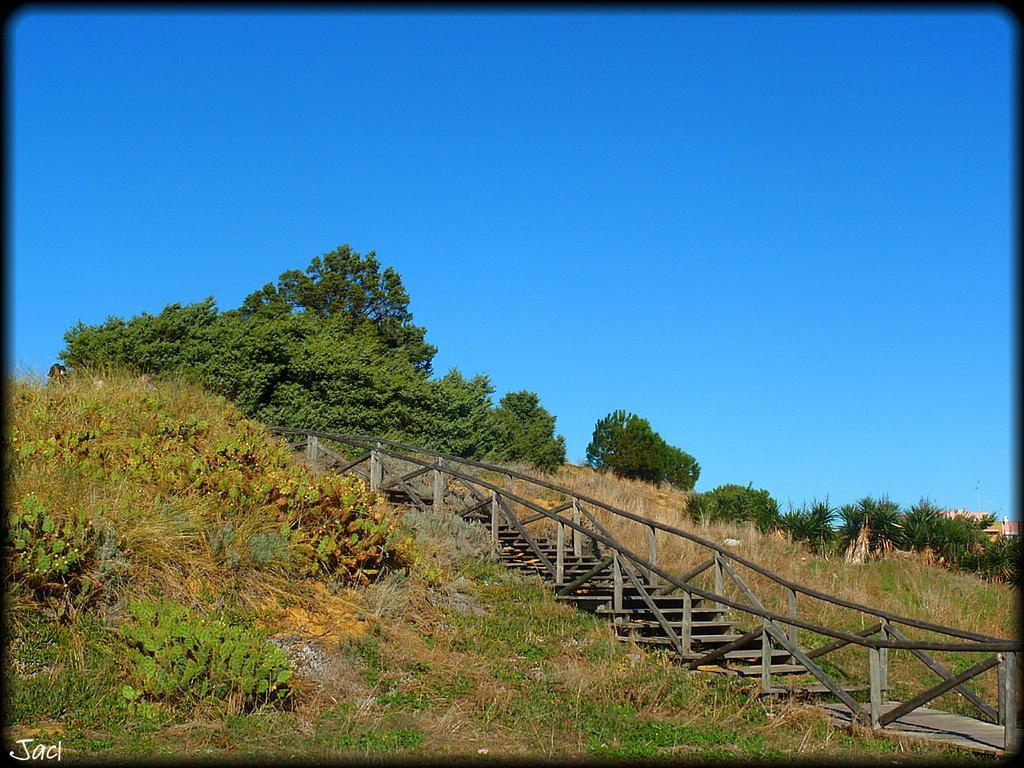Can you describe this image briefly? In this image I can see few trees, grass, houses and few stairs. The sky is in blue color. 